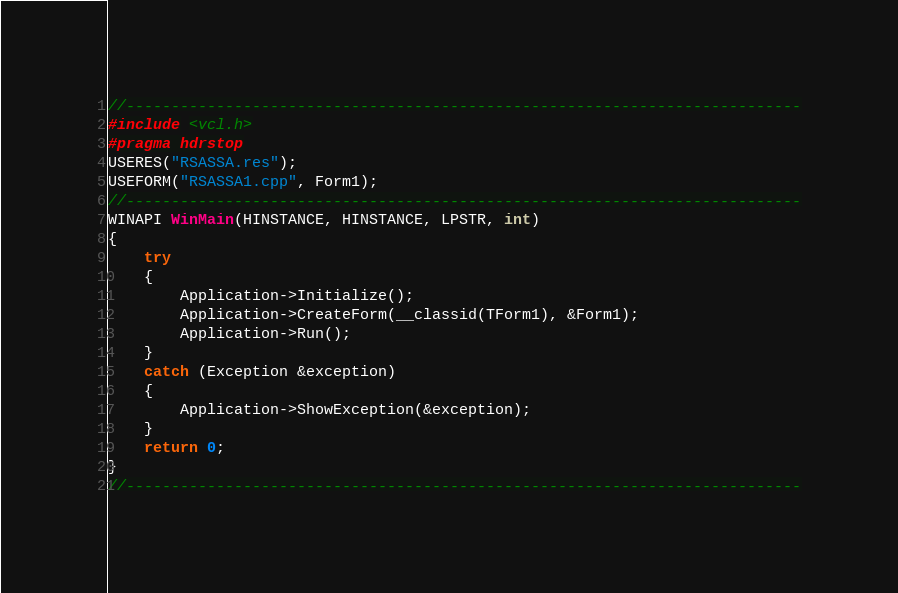Convert code to text. <code><loc_0><loc_0><loc_500><loc_500><_C++_>//---------------------------------------------------------------------------
#include <vcl.h>
#pragma hdrstop
USERES("RSASSA.res");
USEFORM("RSASSA1.cpp", Form1);
//---------------------------------------------------------------------------
WINAPI WinMain(HINSTANCE, HINSTANCE, LPSTR, int)
{
    try
    {
        Application->Initialize();
        Application->CreateForm(__classid(TForm1), &Form1);
        Application->Run();
    }
    catch (Exception &exception)
    {
        Application->ShowException(&exception);
    }
    return 0;
}
//---------------------------------------------------------------------------
</code> 